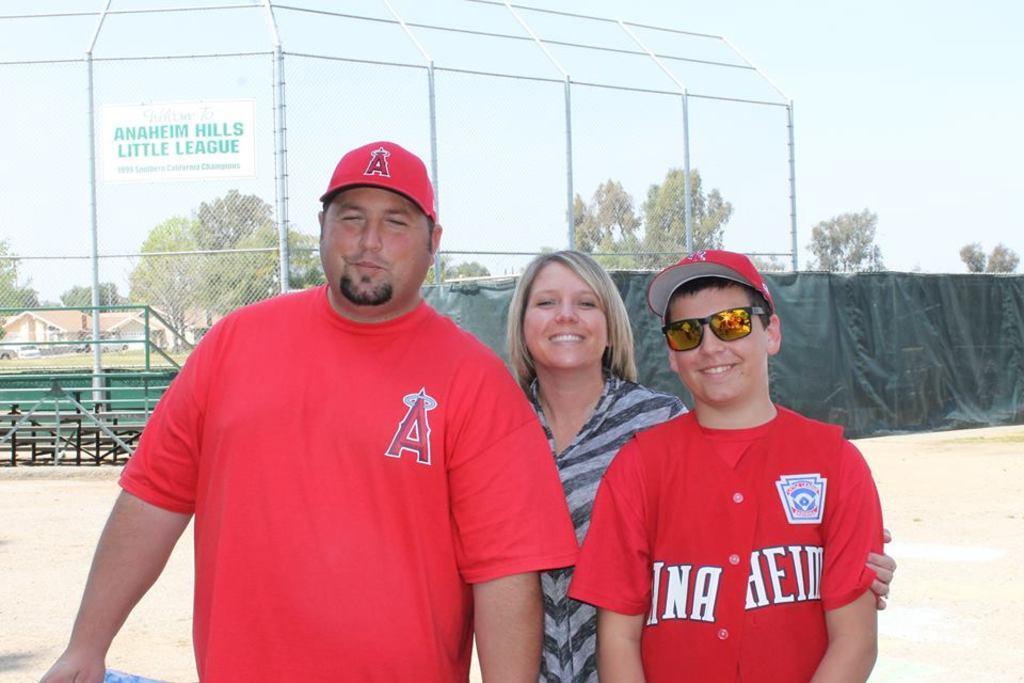How would you summarize this image in a sentence or two? In this image there are three persons standing with a smile on their face, behind them there is a ground with a closed mesh fence, in the background of the image there are trees and houses. 